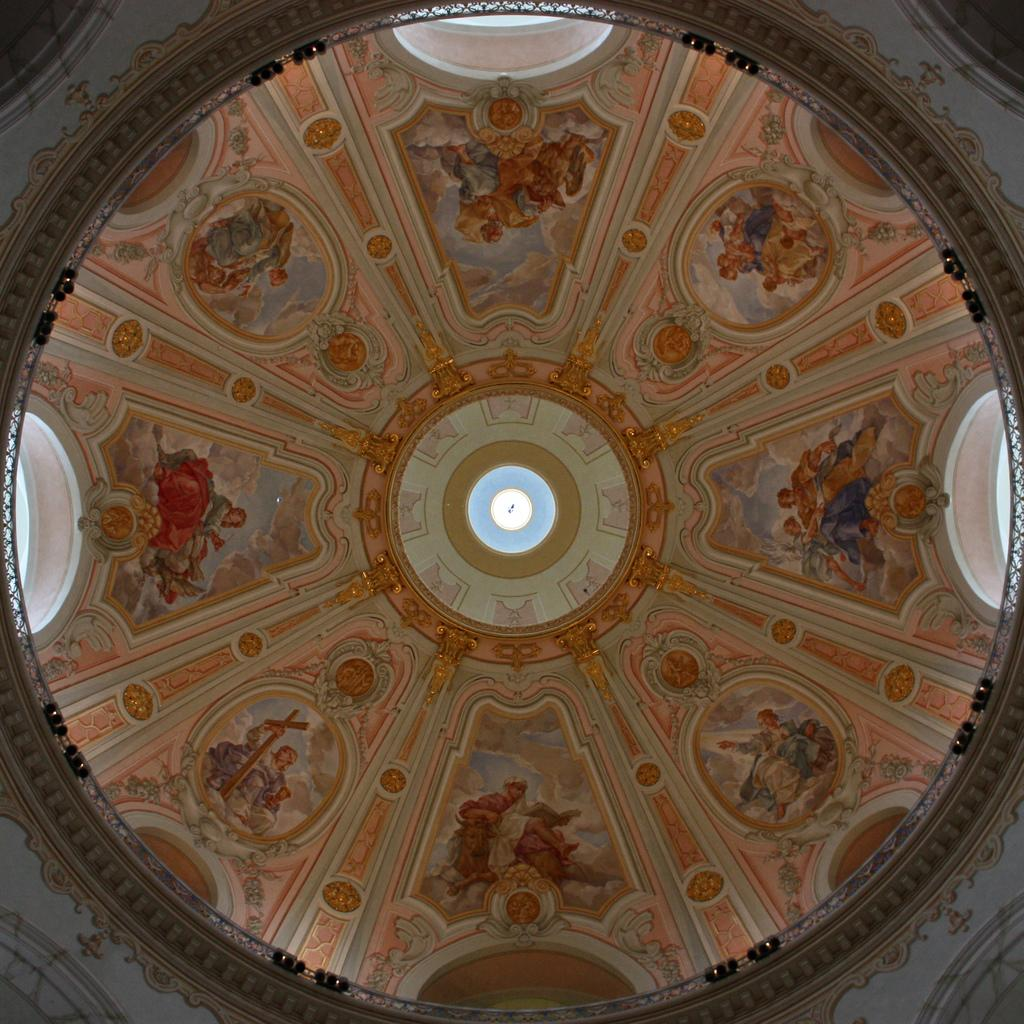What part of a building can be seen in the image? There is a roof part of a building in the image. What type of glass is present in the image? There are stained glasses in the image. What type of doctor can be seen in the image? There is no doctor present in the image; it only features a roof part of a building and stained glasses. How many centimeters long is the drawer in the image? There is no drawer present in the image. 